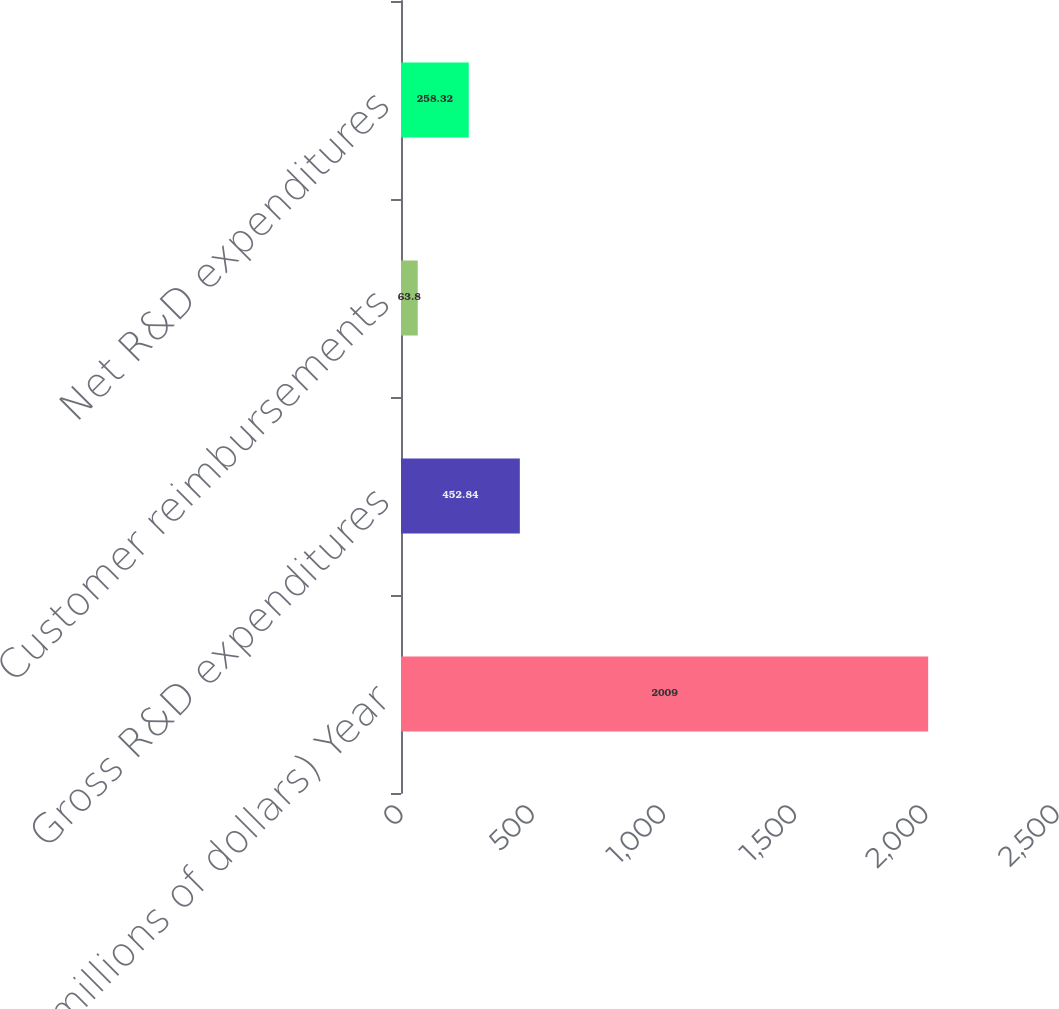Convert chart. <chart><loc_0><loc_0><loc_500><loc_500><bar_chart><fcel>(millions of dollars) Year<fcel>Gross R&D expenditures<fcel>Customer reimbursements<fcel>Net R&D expenditures<nl><fcel>2009<fcel>452.84<fcel>63.8<fcel>258.32<nl></chart> 